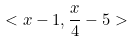<formula> <loc_0><loc_0><loc_500><loc_500>< x - 1 , \frac { x } { 4 } - 5 ></formula> 